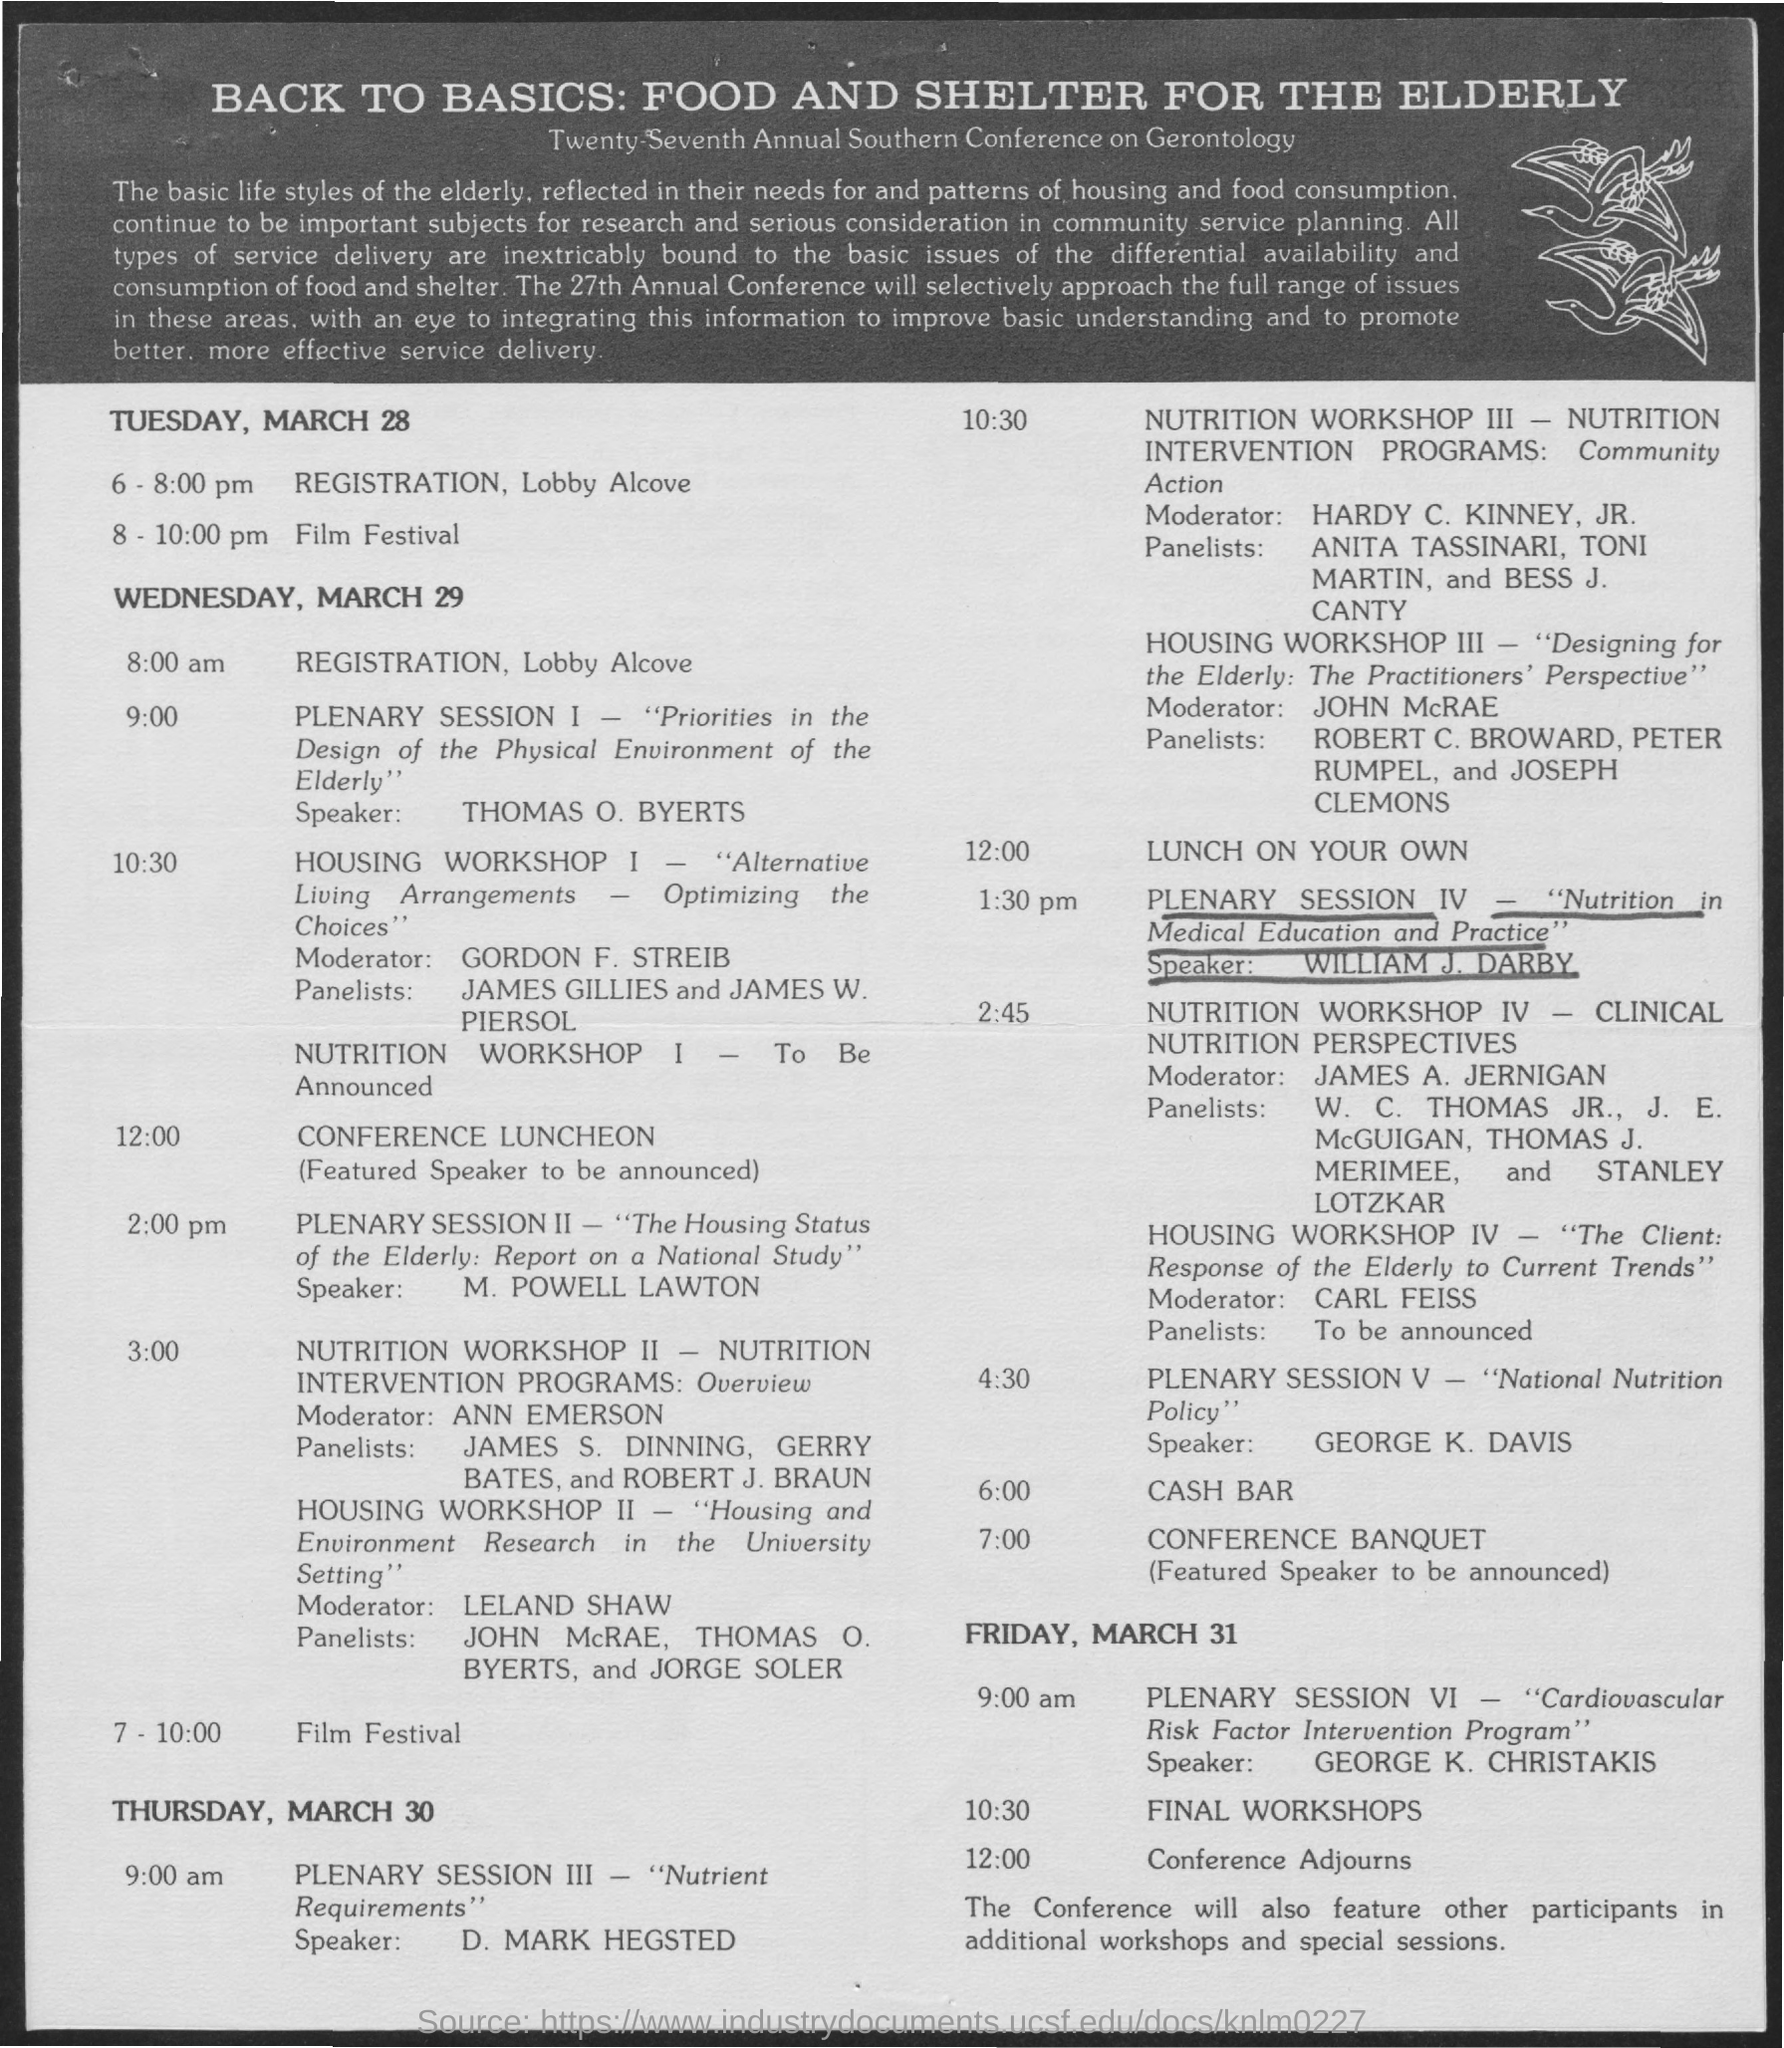Point out several critical features in this image. The registration for Wednesday, March 29th will begin at 8:00 am. The conference banquet will take place at 7:00 pm. The registration for Tuesday, March 28th will take place from 6:00 pm to 8:00 pm. During the Tuesday of March 28, the Film Festival will take place from 8:00 pm to 10:00 pm. 